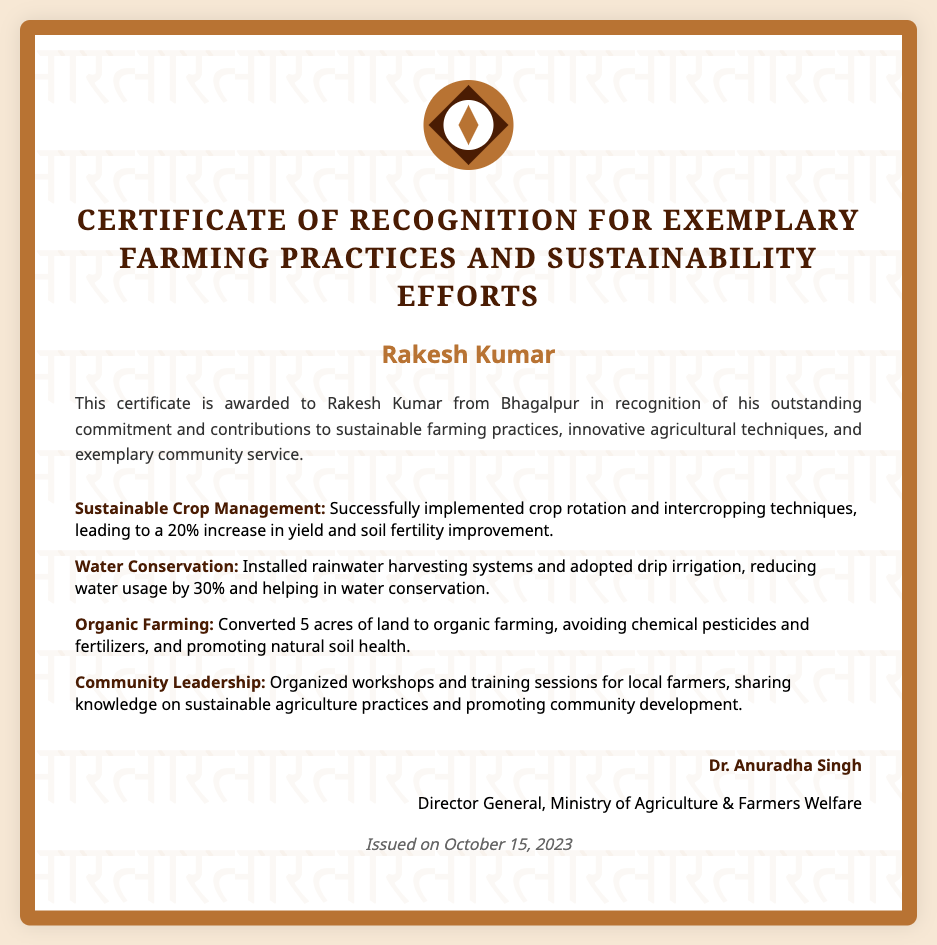what is the title of the certificate? The title of the certificate indicates the purpose and recognition awarded and is stated as "Certificate of Recognition for Exemplary Farming Practices and Sustainability Efforts."
Answer: Certificate of Recognition for Exemplary Farming Practices and Sustainability Efforts who is the recipient of the certificate? The recipient's name is explicitly mentioned in the document.
Answer: Rakesh Kumar what is the date issued? The date when the certificate was issued is provided and is crucial for understanding the recognition timeframe.
Answer: October 15, 2023 what is one sustainable practice mentioned? The document lists various accomplishments and achievements related to sustainable farming, including specific practices.
Answer: Sustainable Crop Management how much did Rakesh Kumar’s yield increase by using sustainable crop management? The document specifies the impact of sustainable crop management on yield, making it easy to assess its effectiveness.
Answer: 20% what organization issued the certificate? The issuer's organization is stated, which is important for understanding the authority behind the recognition.
Answer: Ministry of Agriculture & Farmers Welfare what is the name of the director general? The name of the person who signed the certificate is also mentioned, indicating their authority in issuing the recognition.
Answer: Dr. Anuradha Singh how much water usage was reduced with drip irrigation? The document quantifies the reduction in water usage, which is significant for understanding the impact of the practice.
Answer: 30% 